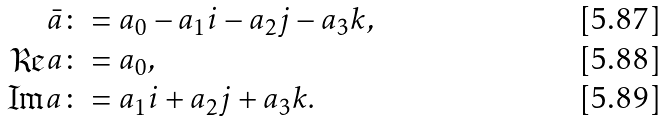<formula> <loc_0><loc_0><loc_500><loc_500>\bar { a } & \colon = a _ { 0 } - a _ { 1 } i - a _ { 2 } j - a _ { 3 } k , \\ \Re a & \colon = a _ { 0 } , \\ \Im a & \colon = a _ { 1 } i + a _ { 2 } j + a _ { 3 } k .</formula> 